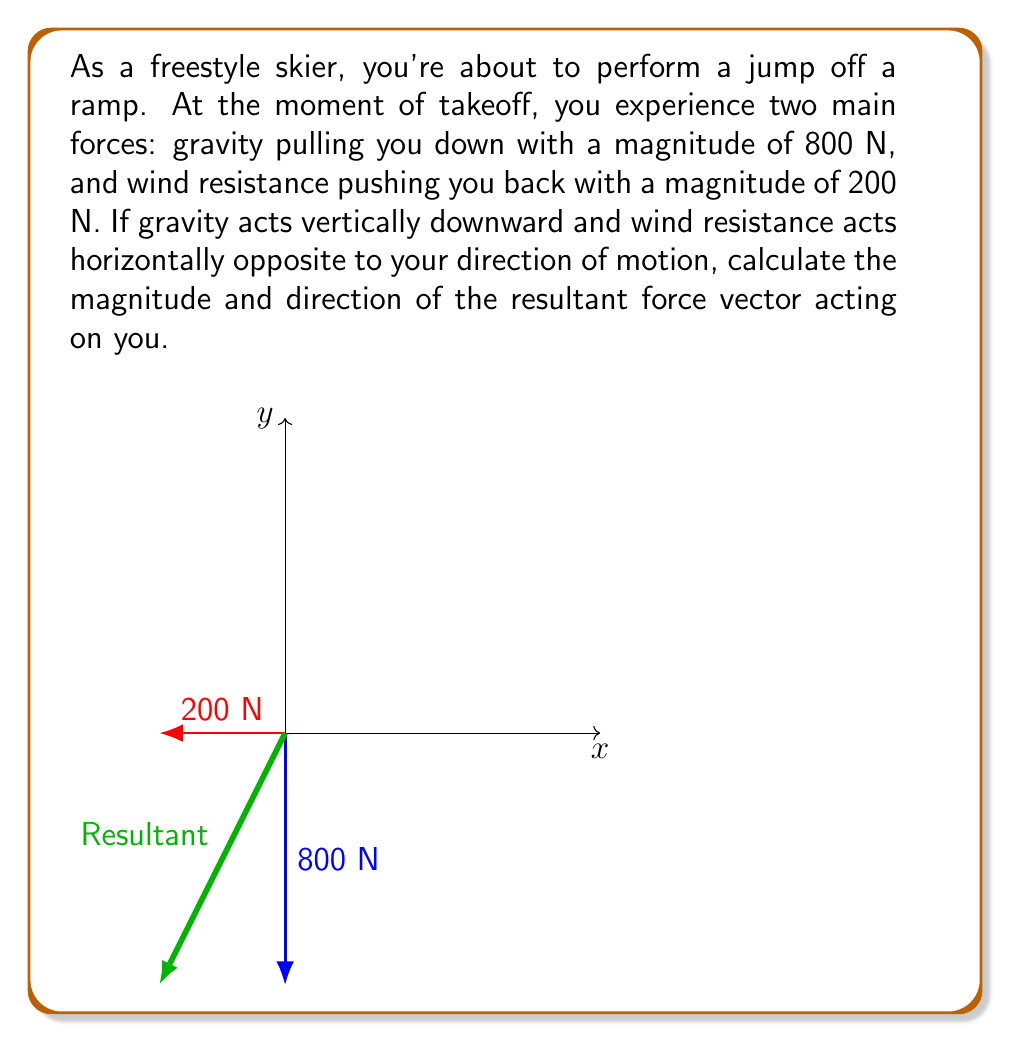Teach me how to tackle this problem. To solve this problem, we'll use vector addition and the Pythagorean theorem. Let's break it down step-by-step:

1) First, let's define our coordinate system:
   - The positive y-axis points upward
   - The positive x-axis points in the direction of motion

2) Now, let's represent our forces as vectors:
   - Gravity: $\vec{F_g} = (0, -800)$ N
   - Wind resistance: $\vec{F_w} = (-200, 0)$ N

3) The resultant force $\vec{F_r}$ is the sum of these vectors:
   $\vec{F_r} = \vec{F_g} + \vec{F_w} = (0, -800) + (-200, 0) = (-200, -800)$ N

4) To find the magnitude of the resultant force, we use the Pythagorean theorem:
   $|\vec{F_r}| = \sqrt{(-200)^2 + (-800)^2} = \sqrt{40,000 + 640,000} = \sqrt{680,000} \approx 824.62$ N

5) To find the direction, we can use the arctangent function:
   $\theta = \arctan(\frac{-800}{-200}) = \arctan(4) \approx 75.96°$

   However, this angle is measured from the negative x-axis. To express it from the positive x-axis (as is conventional), we need to add 180°:
   $75.96° + 180° = 255.96°$

Therefore, the resultant force has a magnitude of approximately 824.62 N and acts at an angle of about 255.96° from the positive x-axis (or 75.96° below the negative x-axis).
Answer: $|\vec{F_r}| \approx 824.62$ N, $\angle \approx 255.96°$ 